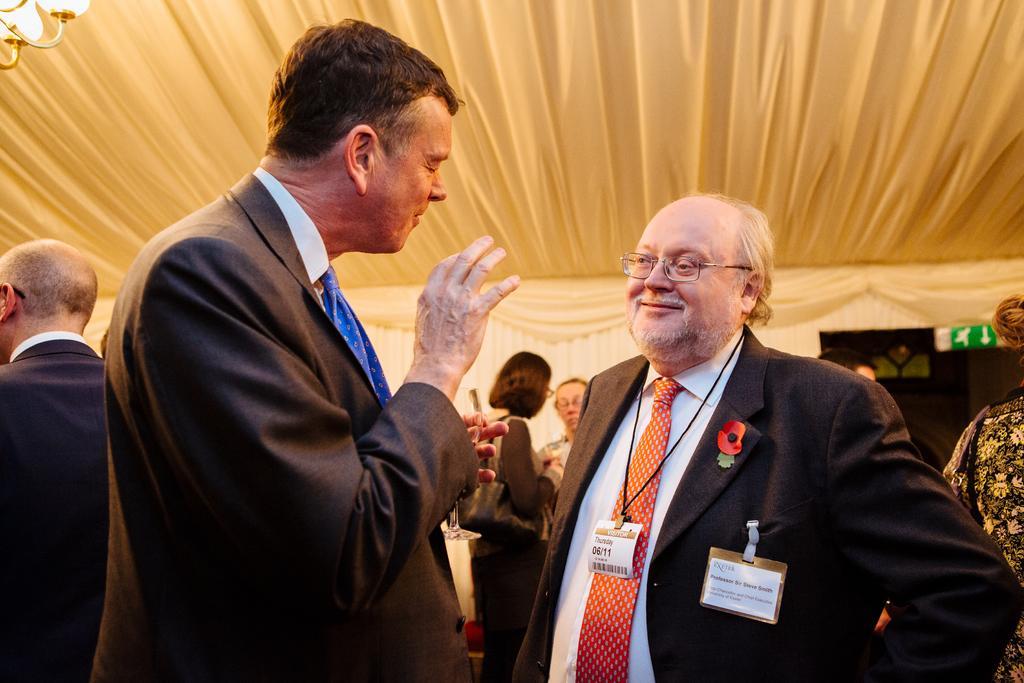Describe this image in one or two sentences. In this picture I can see two persons standing. I can see a man holding a wine glass. There are few people standing. I can see a chandelier and some other objects. 